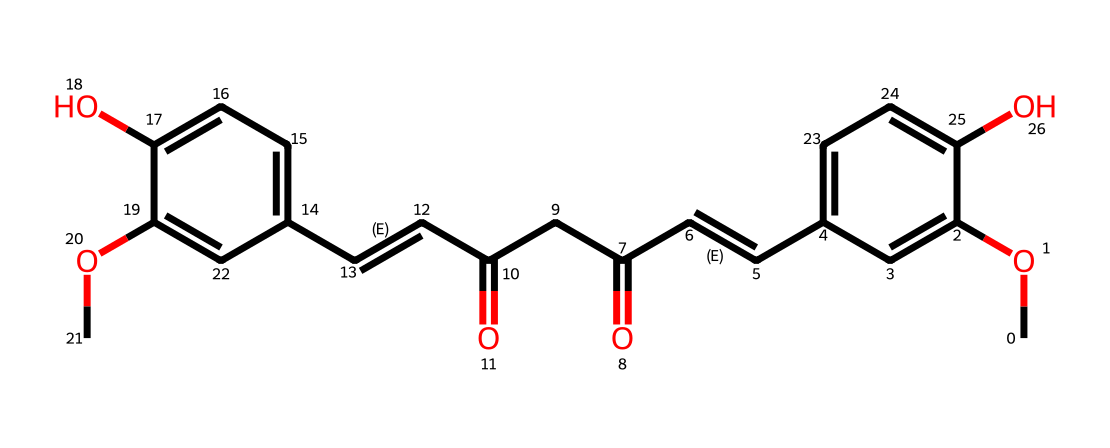What is the molecular formula of curcumin? To determine the molecular formula from the SMILES representation, we count the number of each atom type present. In the SMILES, we identify the presence of carbon (C), hydrogen (H), and oxygen (O) atoms. After analyzing the SMILES, we find that curcumin has 21 carbon atoms, 20 hydrogen atoms, and 6 oxygen atoms, leading to the molecular formula C21H20O6.
Answer: C21H20O6 How many hydroxyl groups are present in curcumin? The presence of hydroxyl groups (-OH) can be identified by looking for -O and connected H in the structure. In the SMILES representation, there are two instances where -OH groups are attached to the aromatic rings, indicating the presence of two hydroxyl groups in curcumin.
Answer: 2 What structural feature contributes to curcumin's color? Curcumin contains conjugated double bonds within its structure, which is a characteristic of polyenes. The alternating double bonds allow for electron delocalization, affecting light absorption and contributing to the yellow color of curcumin.
Answer: conjugated double bonds What type of functional group does curcumin contain? Curcumin contains several functional groups, but the most prominent is the diketone group, as indicated by the presence of two carbonyl (C=O) groups in the structure. This functional group is crucial for the biological activity of curcumin.
Answer: diketone Is curcumin an example of a flavonoid compound? Curcumin is not classified as a flavonoid; it is better identified as a polyphenol due to its structure that includes phenolic compounds. Flavonoids typically have a specific structure with three rings, which curcumin does not have.
Answer: no 